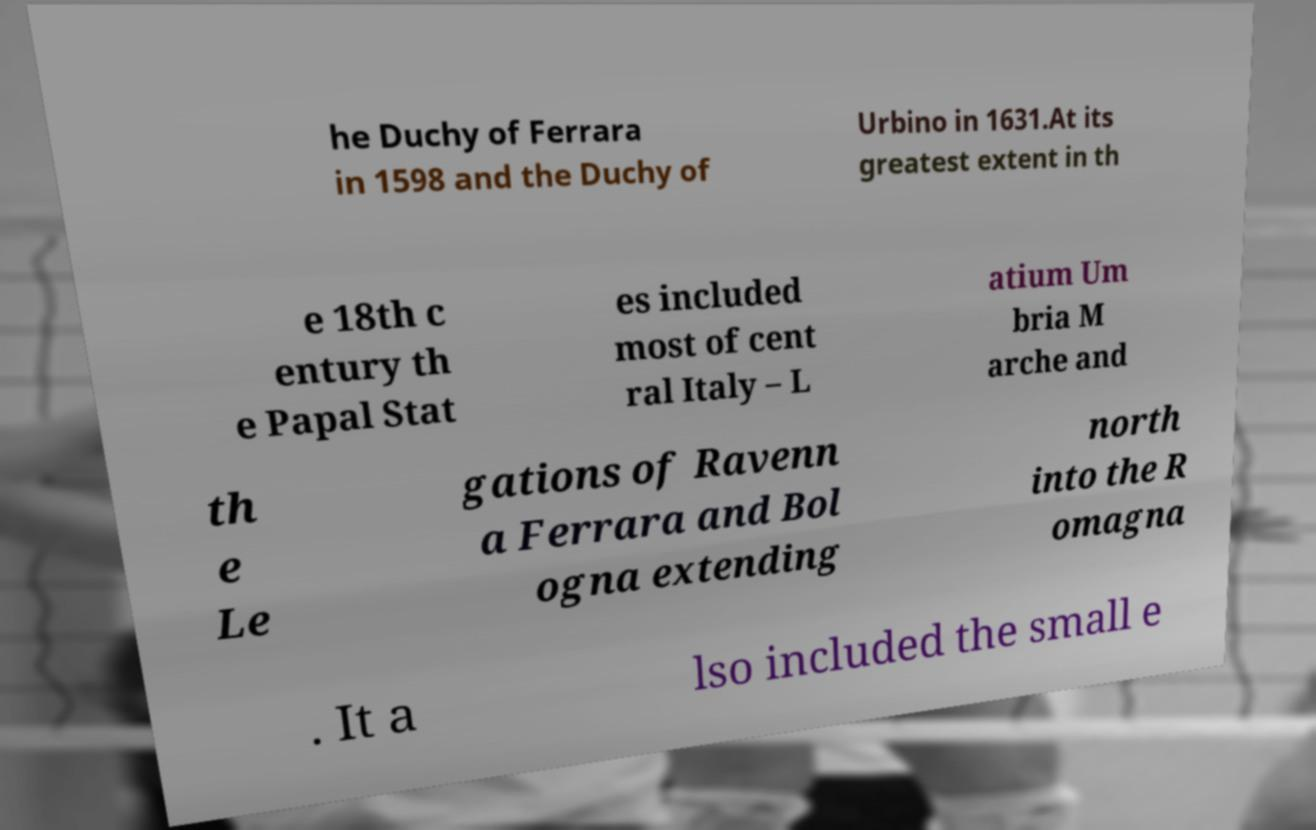For documentation purposes, I need the text within this image transcribed. Could you provide that? he Duchy of Ferrara in 1598 and the Duchy of Urbino in 1631.At its greatest extent in th e 18th c entury th e Papal Stat es included most of cent ral Italy – L atium Um bria M arche and th e Le gations of Ravenn a Ferrara and Bol ogna extending north into the R omagna . It a lso included the small e 